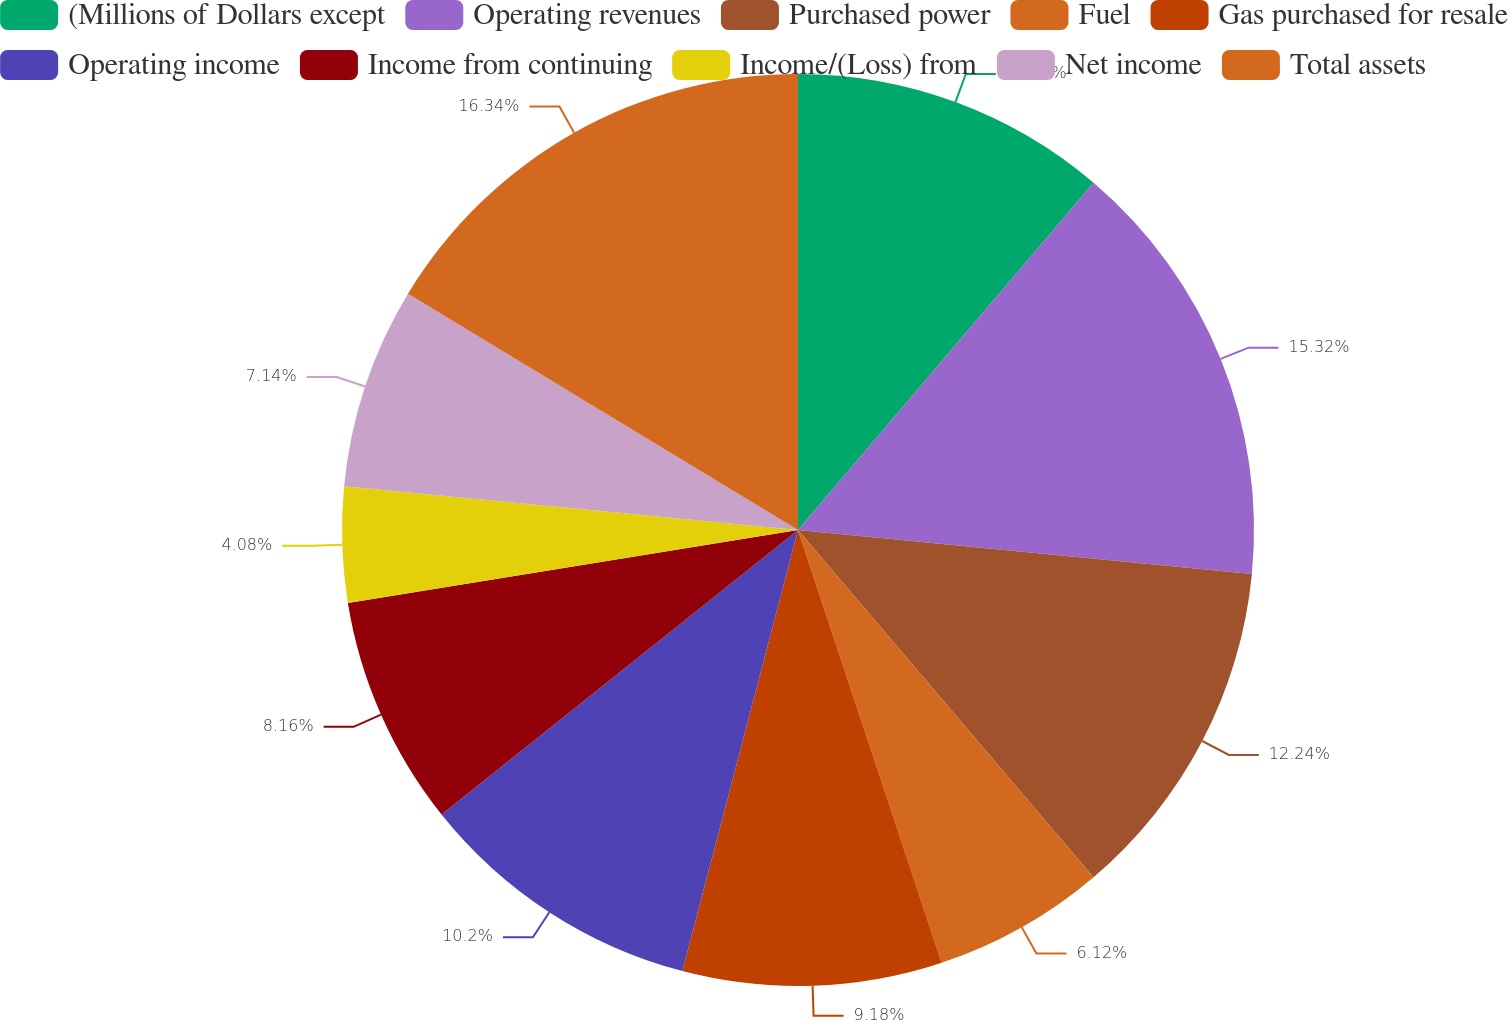Convert chart to OTSL. <chart><loc_0><loc_0><loc_500><loc_500><pie_chart><fcel>(Millions of Dollars except<fcel>Operating revenues<fcel>Purchased power<fcel>Fuel<fcel>Gas purchased for resale<fcel>Operating income<fcel>Income from continuing<fcel>Income/(Loss) from<fcel>Net income<fcel>Total assets<nl><fcel>11.22%<fcel>15.31%<fcel>12.24%<fcel>6.12%<fcel>9.18%<fcel>10.2%<fcel>8.16%<fcel>4.08%<fcel>7.14%<fcel>16.33%<nl></chart> 